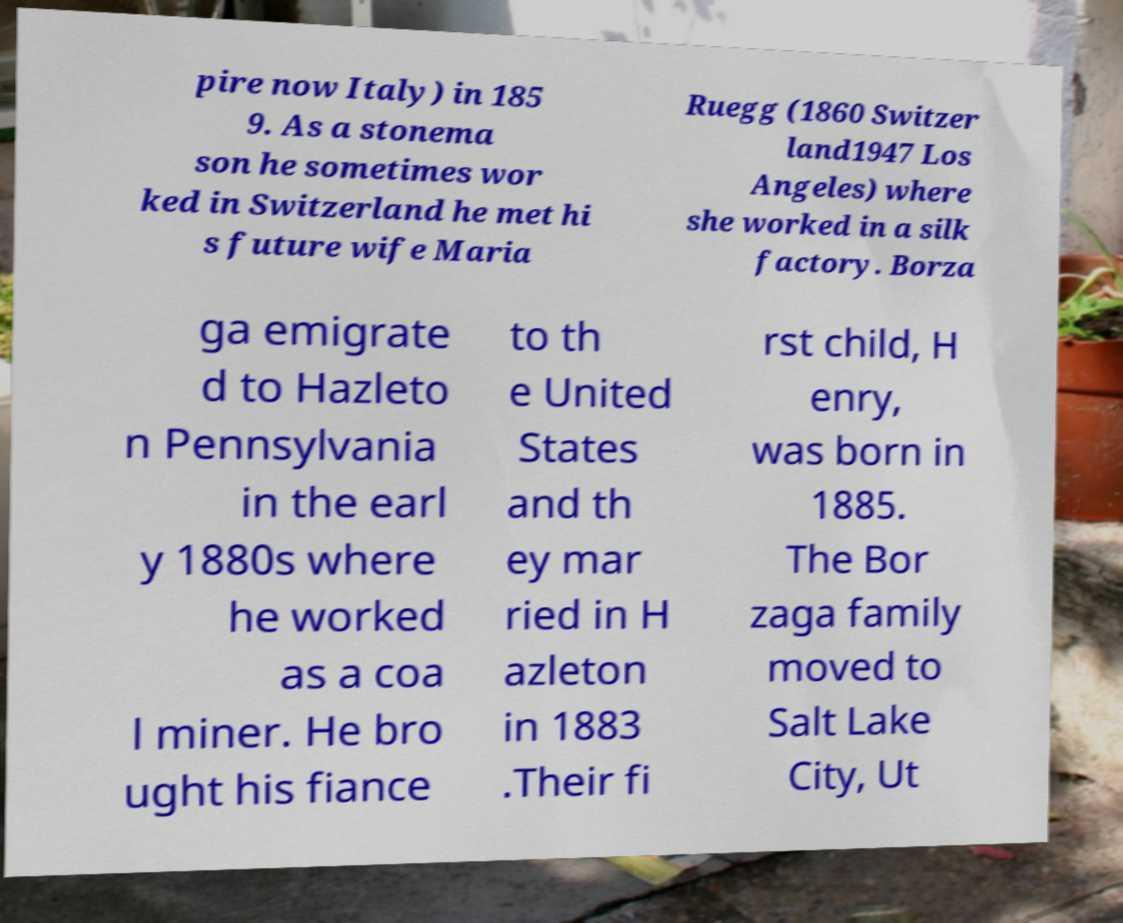For documentation purposes, I need the text within this image transcribed. Could you provide that? pire now Italy) in 185 9. As a stonema son he sometimes wor ked in Switzerland he met hi s future wife Maria Ruegg (1860 Switzer land1947 Los Angeles) where she worked in a silk factory. Borza ga emigrate d to Hazleto n Pennsylvania in the earl y 1880s where he worked as a coa l miner. He bro ught his fiance to th e United States and th ey mar ried in H azleton in 1883 .Their fi rst child, H enry, was born in 1885. The Bor zaga family moved to Salt Lake City, Ut 